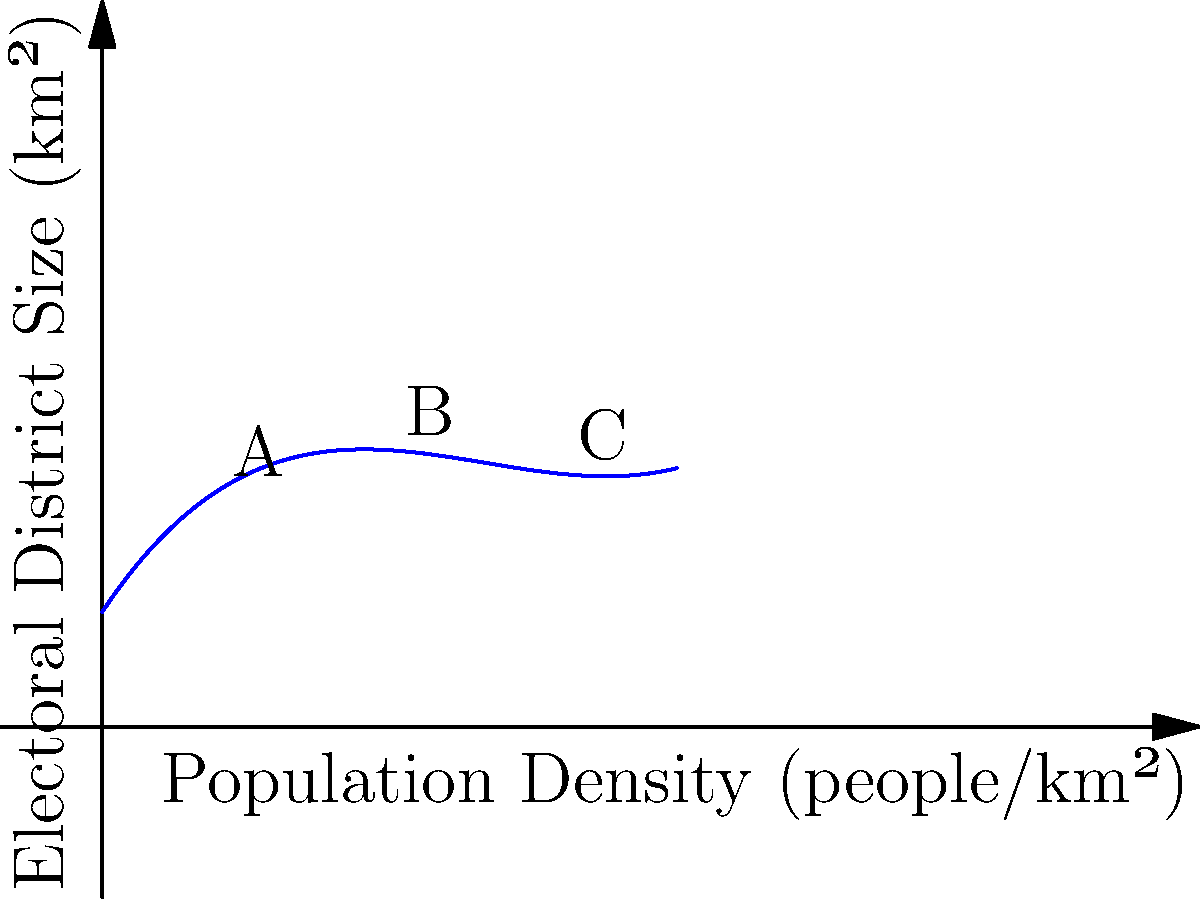The graph shows a polynomial regression curve representing the relationship between population density and electoral district size in a European country. Based on the curve, which point (A, B, or C) represents the most efficient balance between population density and district size for fair representation? To determine the most efficient balance between population density and district size, we need to analyze the curve:

1. Point A (low density): Large district size for a small population, potentially leading to under-representation.

2. Point B (medium density): The curve's inflection point, where the rate of change in district size relative to population density shifts. This represents an optimal balance.

3. Point C (high density): Small district size for a large population, which might lead to over-representation and administrative complexity.

The most efficient balance is at the inflection point of the curve, where the rate of change in district size relative to population density is neither too steep nor too flat. This ensures fair representation across varying population densities.

Point B appears to be closest to this inflection point, representing the most efficient balance between population density and district size.
Answer: B 